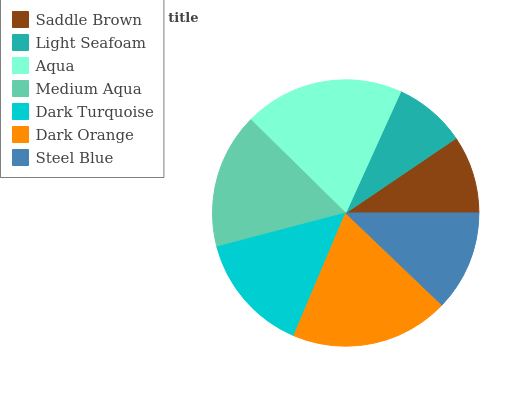Is Light Seafoam the minimum?
Answer yes or no. Yes. Is Aqua the maximum?
Answer yes or no. Yes. Is Aqua the minimum?
Answer yes or no. No. Is Light Seafoam the maximum?
Answer yes or no. No. Is Aqua greater than Light Seafoam?
Answer yes or no. Yes. Is Light Seafoam less than Aqua?
Answer yes or no. Yes. Is Light Seafoam greater than Aqua?
Answer yes or no. No. Is Aqua less than Light Seafoam?
Answer yes or no. No. Is Dark Turquoise the high median?
Answer yes or no. Yes. Is Dark Turquoise the low median?
Answer yes or no. Yes. Is Light Seafoam the high median?
Answer yes or no. No. Is Light Seafoam the low median?
Answer yes or no. No. 